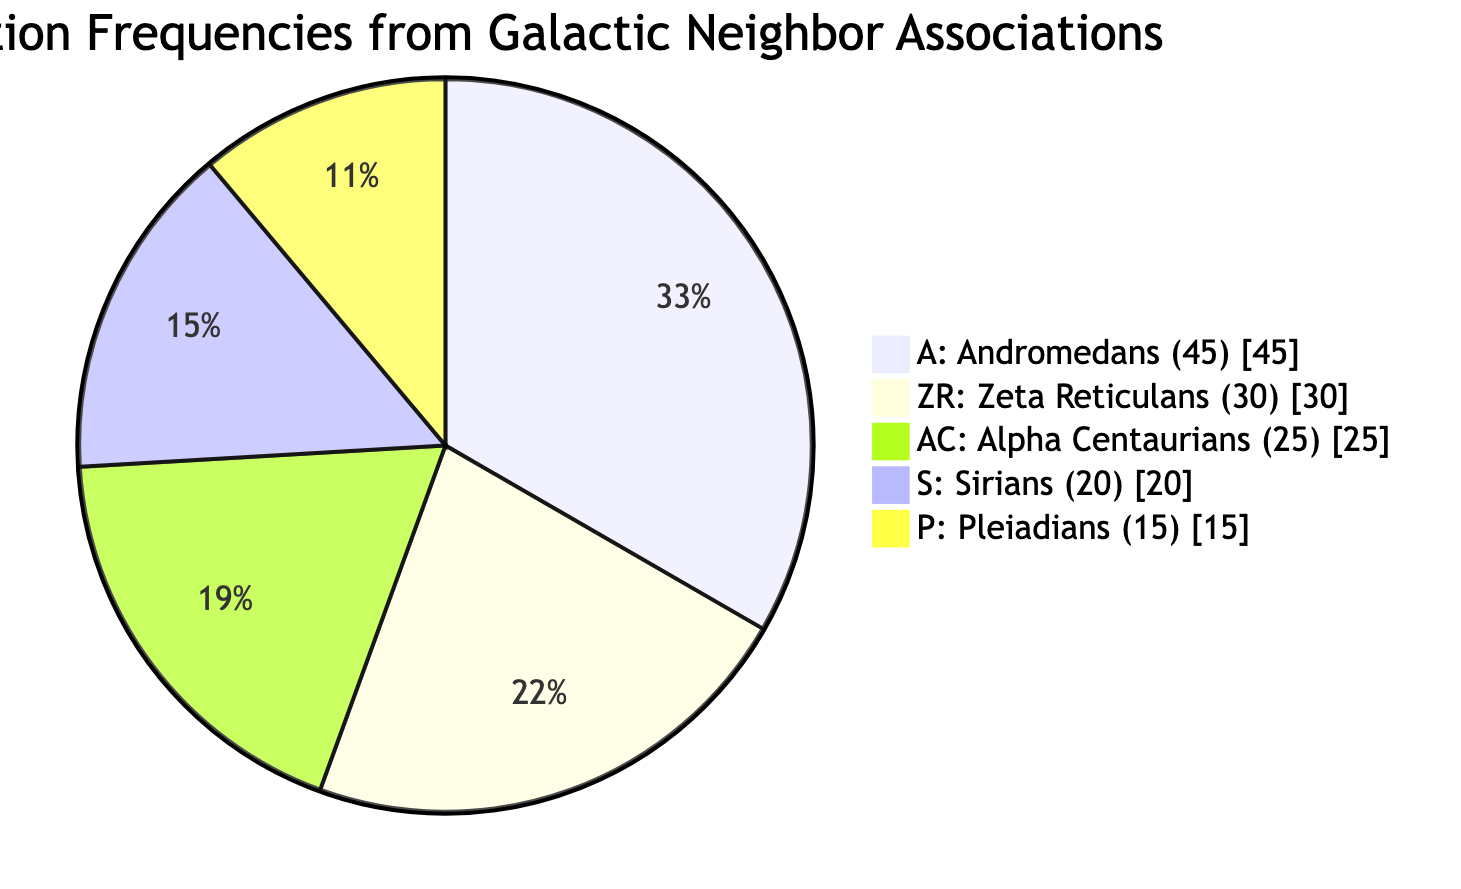What species received the most signals? The pie chart displays different species along with the number of signals received from each. By looking at the largest slice of the pie, which represents the highest value, we can determine that Andromedans received the most signals with a count of 45.
Answer: Andromedans How many signals did Zeta Reticulans send? The pie chart shows a section for Zeta Reticulans indicating they contributed 30 signals in the past month. This information is directly available by identifying the corresponding slice of the chart for Zeta Reticulans.
Answer: 30 What is the total number of signals received from all species? To find the total number of signals, we sum the individual amounts from the pie chart: 45 (Andromedans) + 30 (Zeta Reticulans) + 25 (Alpha Centaurians) + 20 (Sirians) + 15 (Pleiadians) = 165. This gives us the complete count of signals received across all categories.
Answer: 165 Which species contributed the least signals? By examining the pie chart, we look for the smallest slice, which corresponds to the species contributing the least signals. This can be identified as Pleiadians with a total of 15 signals, as their section is the smallest part of the diagram.
Answer: Pleiadians How does the signal contribution of Sirians compare to that of Alpha Centaurians? The pie chart indicates that Sirians sent 20 signals and Alpha Centaurians sent 25 signals. Comparing these two values, we see that Alpha Centaurians contributed more signals due to their higher count.
Answer: Alpha Centaurians What portion of the total signals did Andromedans represent? To find the portion of total signals represented by Andromedans, we take their signal count (45) and divide it by the total signals count (165), giving us the fraction of signals from Andromedans. This can be expressed as approximately 27.27% when calculated.
Answer: 27.27% How many more signals did Zeta Reticulans send than Pleiadians? By looking at the pie chart, we see that Zeta Reticulans sent 30 signals and Pleiadians sent 15 signals. The difference is calculated as 30 - 15, which shows the number of additional signals from Zeta Reticulans compared to Pleiadians.
Answer: 15 Which two species have a combined total of 55 signals? Examining the counts from the pie chart, Andromedans (45) and Zeta Reticulans (30) together have a sum of 75, but if we take Sirians (20) and Pleiadians (15), they combine to total 35. Only checking the counts reveals that Sirians and Alpha Centaurians (20 + 25) yield 45. Upon reviewing others, it is actually Zeta Reticulans (30) and Alpha Centaurians (25), yielding a total of 55 when summed.
Answer: Zeta Reticulans and Alpha Centaurians 